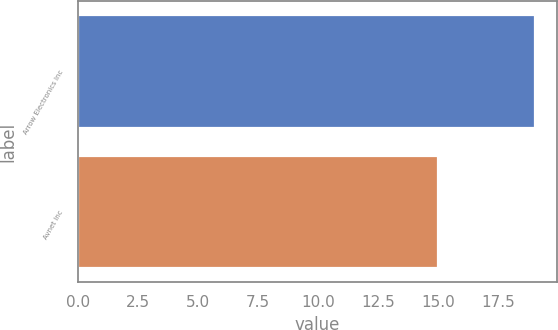Convert chart. <chart><loc_0><loc_0><loc_500><loc_500><bar_chart><fcel>Arrow Electronics Inc<fcel>Avnet Inc<nl><fcel>19<fcel>15<nl></chart> 